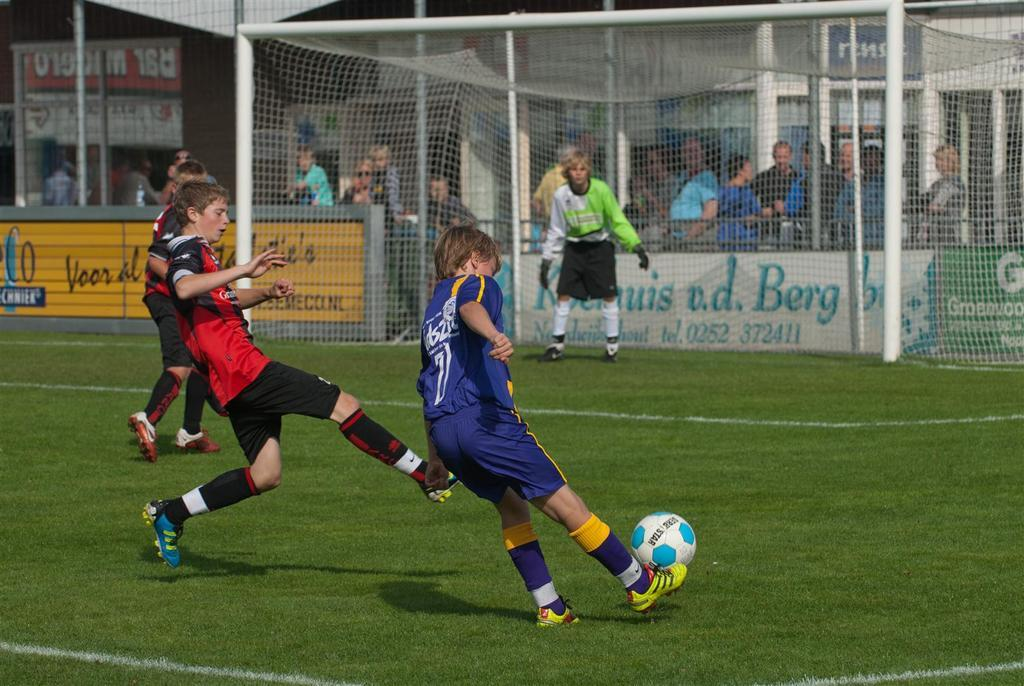<image>
Create a compact narrative representing the image presented. the word Berg is on the sign behind the goal 